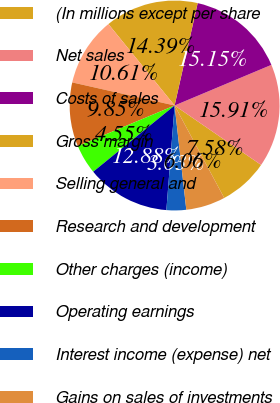Convert chart to OTSL. <chart><loc_0><loc_0><loc_500><loc_500><pie_chart><fcel>(In millions except per share<fcel>Net sales<fcel>Costs of sales<fcel>Gross margin<fcel>Selling general and<fcel>Research and development<fcel>Other charges (income)<fcel>Operating earnings<fcel>Interest income (expense) net<fcel>Gains on sales of investments<nl><fcel>7.58%<fcel>15.91%<fcel>15.15%<fcel>14.39%<fcel>10.61%<fcel>9.85%<fcel>4.55%<fcel>12.88%<fcel>3.03%<fcel>6.06%<nl></chart> 